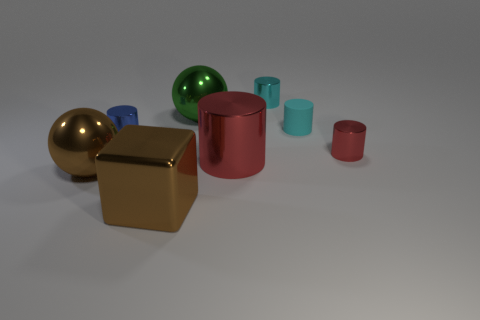Subtract all gray cylinders. Subtract all yellow cubes. How many cylinders are left? 5 Add 2 cyan metal cubes. How many objects exist? 10 Subtract all spheres. How many objects are left? 6 Subtract 0 yellow cubes. How many objects are left? 8 Subtract all big brown metallic balls. Subtract all green objects. How many objects are left? 6 Add 3 green shiny spheres. How many green shiny spheres are left? 4 Add 5 large red blocks. How many large red blocks exist? 5 